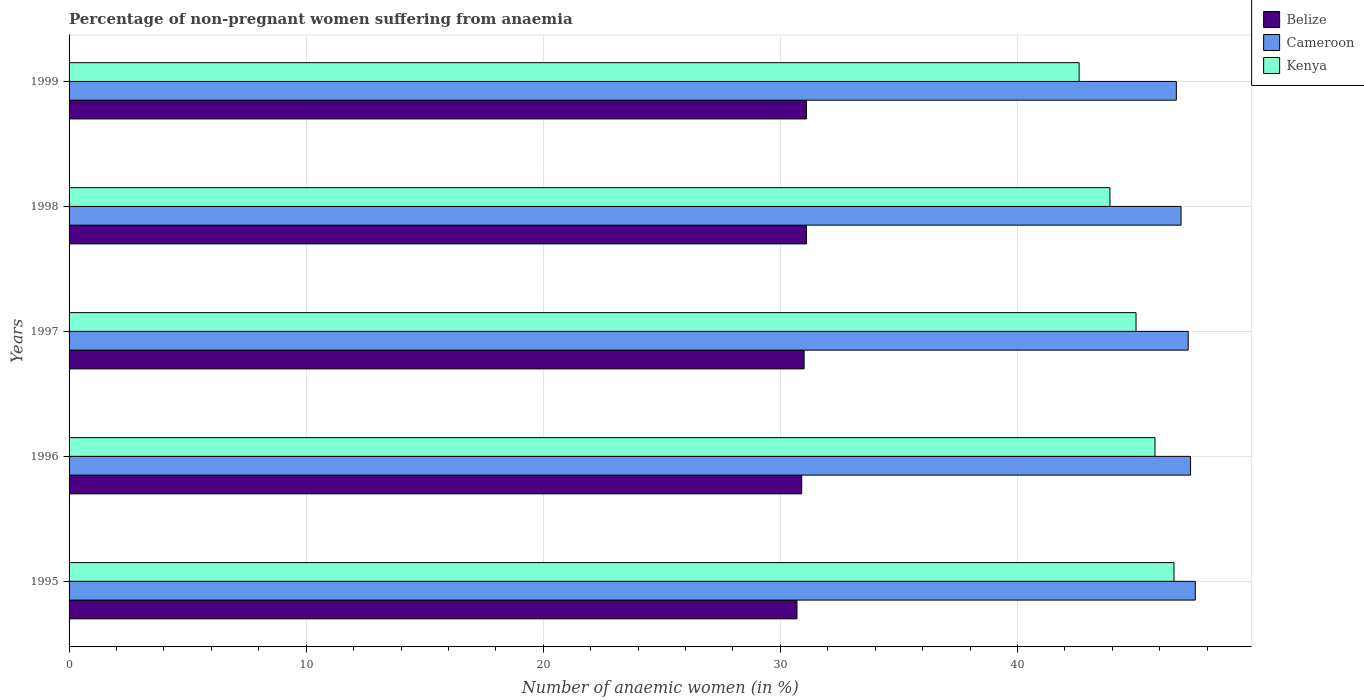How many groups of bars are there?
Your answer should be compact. 5. How many bars are there on the 4th tick from the top?
Keep it short and to the point. 3. In how many cases, is the number of bars for a given year not equal to the number of legend labels?
Offer a terse response. 0. Across all years, what is the maximum percentage of non-pregnant women suffering from anaemia in Kenya?
Provide a short and direct response. 46.6. Across all years, what is the minimum percentage of non-pregnant women suffering from anaemia in Cameroon?
Your answer should be compact. 46.7. In which year was the percentage of non-pregnant women suffering from anaemia in Kenya minimum?
Your answer should be very brief. 1999. What is the total percentage of non-pregnant women suffering from anaemia in Belize in the graph?
Offer a very short reply. 154.8. What is the difference between the percentage of non-pregnant women suffering from anaemia in Belize in 1995 and that in 1996?
Your answer should be compact. -0.2. What is the difference between the percentage of non-pregnant women suffering from anaemia in Kenya in 1996 and the percentage of non-pregnant women suffering from anaemia in Belize in 1998?
Offer a terse response. 14.7. What is the average percentage of non-pregnant women suffering from anaemia in Kenya per year?
Offer a terse response. 44.78. In the year 1996, what is the difference between the percentage of non-pregnant women suffering from anaemia in Belize and percentage of non-pregnant women suffering from anaemia in Kenya?
Your answer should be compact. -14.9. In how many years, is the percentage of non-pregnant women suffering from anaemia in Kenya greater than 46 %?
Offer a terse response. 1. What is the ratio of the percentage of non-pregnant women suffering from anaemia in Belize in 1995 to that in 1999?
Keep it short and to the point. 0.99. Is the percentage of non-pregnant women suffering from anaemia in Belize in 1996 less than that in 1997?
Your response must be concise. Yes. What is the difference between the highest and the second highest percentage of non-pregnant women suffering from anaemia in Kenya?
Provide a succinct answer. 0.8. What is the difference between the highest and the lowest percentage of non-pregnant women suffering from anaemia in Belize?
Make the answer very short. 0.4. Is the sum of the percentage of non-pregnant women suffering from anaemia in Cameroon in 1995 and 1996 greater than the maximum percentage of non-pregnant women suffering from anaemia in Belize across all years?
Offer a terse response. Yes. What does the 3rd bar from the top in 1999 represents?
Your answer should be very brief. Belize. What does the 3rd bar from the bottom in 1996 represents?
Provide a short and direct response. Kenya. Is it the case that in every year, the sum of the percentage of non-pregnant women suffering from anaemia in Belize and percentage of non-pregnant women suffering from anaemia in Kenya is greater than the percentage of non-pregnant women suffering from anaemia in Cameroon?
Give a very brief answer. Yes. Are the values on the major ticks of X-axis written in scientific E-notation?
Keep it short and to the point. No. How many legend labels are there?
Give a very brief answer. 3. What is the title of the graph?
Your response must be concise. Percentage of non-pregnant women suffering from anaemia. What is the label or title of the X-axis?
Your answer should be very brief. Number of anaemic women (in %). What is the label or title of the Y-axis?
Ensure brevity in your answer.  Years. What is the Number of anaemic women (in %) of Belize in 1995?
Offer a very short reply. 30.7. What is the Number of anaemic women (in %) in Cameroon in 1995?
Your response must be concise. 47.5. What is the Number of anaemic women (in %) in Kenya in 1995?
Your answer should be compact. 46.6. What is the Number of anaemic women (in %) of Belize in 1996?
Offer a terse response. 30.9. What is the Number of anaemic women (in %) in Cameroon in 1996?
Your response must be concise. 47.3. What is the Number of anaemic women (in %) in Kenya in 1996?
Offer a terse response. 45.8. What is the Number of anaemic women (in %) in Belize in 1997?
Keep it short and to the point. 31. What is the Number of anaemic women (in %) of Cameroon in 1997?
Your answer should be compact. 47.2. What is the Number of anaemic women (in %) in Kenya in 1997?
Keep it short and to the point. 45. What is the Number of anaemic women (in %) of Belize in 1998?
Provide a succinct answer. 31.1. What is the Number of anaemic women (in %) of Cameroon in 1998?
Your answer should be very brief. 46.9. What is the Number of anaemic women (in %) of Kenya in 1998?
Make the answer very short. 43.9. What is the Number of anaemic women (in %) of Belize in 1999?
Your answer should be compact. 31.1. What is the Number of anaemic women (in %) in Cameroon in 1999?
Offer a terse response. 46.7. What is the Number of anaemic women (in %) in Kenya in 1999?
Your answer should be compact. 42.6. Across all years, what is the maximum Number of anaemic women (in %) of Belize?
Give a very brief answer. 31.1. Across all years, what is the maximum Number of anaemic women (in %) of Cameroon?
Make the answer very short. 47.5. Across all years, what is the maximum Number of anaemic women (in %) in Kenya?
Make the answer very short. 46.6. Across all years, what is the minimum Number of anaemic women (in %) in Belize?
Your answer should be compact. 30.7. Across all years, what is the minimum Number of anaemic women (in %) in Cameroon?
Provide a short and direct response. 46.7. Across all years, what is the minimum Number of anaemic women (in %) of Kenya?
Provide a short and direct response. 42.6. What is the total Number of anaemic women (in %) of Belize in the graph?
Your answer should be compact. 154.8. What is the total Number of anaemic women (in %) of Cameroon in the graph?
Ensure brevity in your answer.  235.6. What is the total Number of anaemic women (in %) of Kenya in the graph?
Ensure brevity in your answer.  223.9. What is the difference between the Number of anaemic women (in %) of Belize in 1995 and that in 1996?
Keep it short and to the point. -0.2. What is the difference between the Number of anaemic women (in %) in Cameroon in 1995 and that in 1996?
Your answer should be very brief. 0.2. What is the difference between the Number of anaemic women (in %) of Kenya in 1995 and that in 1996?
Make the answer very short. 0.8. What is the difference between the Number of anaemic women (in %) of Cameroon in 1995 and that in 1997?
Offer a very short reply. 0.3. What is the difference between the Number of anaemic women (in %) of Kenya in 1995 and that in 1997?
Offer a very short reply. 1.6. What is the difference between the Number of anaemic women (in %) in Kenya in 1995 and that in 1998?
Your response must be concise. 2.7. What is the difference between the Number of anaemic women (in %) in Kenya in 1995 and that in 1999?
Offer a terse response. 4. What is the difference between the Number of anaemic women (in %) of Kenya in 1996 and that in 1998?
Your answer should be very brief. 1.9. What is the difference between the Number of anaemic women (in %) in Belize in 1997 and that in 1998?
Your answer should be compact. -0.1. What is the difference between the Number of anaemic women (in %) of Cameroon in 1997 and that in 1998?
Ensure brevity in your answer.  0.3. What is the difference between the Number of anaemic women (in %) of Kenya in 1997 and that in 1998?
Provide a succinct answer. 1.1. What is the difference between the Number of anaemic women (in %) of Belize in 1997 and that in 1999?
Ensure brevity in your answer.  -0.1. What is the difference between the Number of anaemic women (in %) in Cameroon in 1998 and that in 1999?
Provide a short and direct response. 0.2. What is the difference between the Number of anaemic women (in %) of Belize in 1995 and the Number of anaemic women (in %) of Cameroon in 1996?
Offer a terse response. -16.6. What is the difference between the Number of anaemic women (in %) of Belize in 1995 and the Number of anaemic women (in %) of Kenya in 1996?
Provide a succinct answer. -15.1. What is the difference between the Number of anaemic women (in %) in Cameroon in 1995 and the Number of anaemic women (in %) in Kenya in 1996?
Your answer should be very brief. 1.7. What is the difference between the Number of anaemic women (in %) in Belize in 1995 and the Number of anaemic women (in %) in Cameroon in 1997?
Your answer should be compact. -16.5. What is the difference between the Number of anaemic women (in %) of Belize in 1995 and the Number of anaemic women (in %) of Kenya in 1997?
Give a very brief answer. -14.3. What is the difference between the Number of anaemic women (in %) in Cameroon in 1995 and the Number of anaemic women (in %) in Kenya in 1997?
Your response must be concise. 2.5. What is the difference between the Number of anaemic women (in %) in Belize in 1995 and the Number of anaemic women (in %) in Cameroon in 1998?
Provide a succinct answer. -16.2. What is the difference between the Number of anaemic women (in %) of Belize in 1995 and the Number of anaemic women (in %) of Cameroon in 1999?
Your response must be concise. -16. What is the difference between the Number of anaemic women (in %) of Belize in 1995 and the Number of anaemic women (in %) of Kenya in 1999?
Your response must be concise. -11.9. What is the difference between the Number of anaemic women (in %) in Belize in 1996 and the Number of anaemic women (in %) in Cameroon in 1997?
Your answer should be compact. -16.3. What is the difference between the Number of anaemic women (in %) of Belize in 1996 and the Number of anaemic women (in %) of Kenya in 1997?
Your response must be concise. -14.1. What is the difference between the Number of anaemic women (in %) of Belize in 1996 and the Number of anaemic women (in %) of Kenya in 1998?
Offer a very short reply. -13. What is the difference between the Number of anaemic women (in %) in Cameroon in 1996 and the Number of anaemic women (in %) in Kenya in 1998?
Your answer should be very brief. 3.4. What is the difference between the Number of anaemic women (in %) in Belize in 1996 and the Number of anaemic women (in %) in Cameroon in 1999?
Give a very brief answer. -15.8. What is the difference between the Number of anaemic women (in %) in Belize in 1996 and the Number of anaemic women (in %) in Kenya in 1999?
Give a very brief answer. -11.7. What is the difference between the Number of anaemic women (in %) in Belize in 1997 and the Number of anaemic women (in %) in Cameroon in 1998?
Ensure brevity in your answer.  -15.9. What is the difference between the Number of anaemic women (in %) of Cameroon in 1997 and the Number of anaemic women (in %) of Kenya in 1998?
Make the answer very short. 3.3. What is the difference between the Number of anaemic women (in %) in Belize in 1997 and the Number of anaemic women (in %) in Cameroon in 1999?
Offer a very short reply. -15.7. What is the difference between the Number of anaemic women (in %) of Belize in 1997 and the Number of anaemic women (in %) of Kenya in 1999?
Your response must be concise. -11.6. What is the difference between the Number of anaemic women (in %) of Belize in 1998 and the Number of anaemic women (in %) of Cameroon in 1999?
Offer a very short reply. -15.6. What is the difference between the Number of anaemic women (in %) in Belize in 1998 and the Number of anaemic women (in %) in Kenya in 1999?
Your answer should be very brief. -11.5. What is the difference between the Number of anaemic women (in %) of Cameroon in 1998 and the Number of anaemic women (in %) of Kenya in 1999?
Make the answer very short. 4.3. What is the average Number of anaemic women (in %) in Belize per year?
Give a very brief answer. 30.96. What is the average Number of anaemic women (in %) in Cameroon per year?
Provide a short and direct response. 47.12. What is the average Number of anaemic women (in %) in Kenya per year?
Your answer should be compact. 44.78. In the year 1995, what is the difference between the Number of anaemic women (in %) of Belize and Number of anaemic women (in %) of Cameroon?
Your answer should be compact. -16.8. In the year 1995, what is the difference between the Number of anaemic women (in %) in Belize and Number of anaemic women (in %) in Kenya?
Give a very brief answer. -15.9. In the year 1996, what is the difference between the Number of anaemic women (in %) in Belize and Number of anaemic women (in %) in Cameroon?
Ensure brevity in your answer.  -16.4. In the year 1996, what is the difference between the Number of anaemic women (in %) of Belize and Number of anaemic women (in %) of Kenya?
Give a very brief answer. -14.9. In the year 1996, what is the difference between the Number of anaemic women (in %) in Cameroon and Number of anaemic women (in %) in Kenya?
Give a very brief answer. 1.5. In the year 1997, what is the difference between the Number of anaemic women (in %) of Belize and Number of anaemic women (in %) of Cameroon?
Your answer should be very brief. -16.2. In the year 1998, what is the difference between the Number of anaemic women (in %) of Belize and Number of anaemic women (in %) of Cameroon?
Offer a very short reply. -15.8. In the year 1998, what is the difference between the Number of anaemic women (in %) of Belize and Number of anaemic women (in %) of Kenya?
Keep it short and to the point. -12.8. In the year 1999, what is the difference between the Number of anaemic women (in %) in Belize and Number of anaemic women (in %) in Cameroon?
Ensure brevity in your answer.  -15.6. In the year 1999, what is the difference between the Number of anaemic women (in %) of Belize and Number of anaemic women (in %) of Kenya?
Offer a terse response. -11.5. What is the ratio of the Number of anaemic women (in %) in Belize in 1995 to that in 1996?
Offer a terse response. 0.99. What is the ratio of the Number of anaemic women (in %) in Kenya in 1995 to that in 1996?
Provide a short and direct response. 1.02. What is the ratio of the Number of anaemic women (in %) of Belize in 1995 to that in 1997?
Offer a very short reply. 0.99. What is the ratio of the Number of anaemic women (in %) of Cameroon in 1995 to that in 1997?
Provide a short and direct response. 1.01. What is the ratio of the Number of anaemic women (in %) in Kenya in 1995 to that in 1997?
Offer a very short reply. 1.04. What is the ratio of the Number of anaemic women (in %) of Belize in 1995 to that in 1998?
Offer a very short reply. 0.99. What is the ratio of the Number of anaemic women (in %) of Cameroon in 1995 to that in 1998?
Make the answer very short. 1.01. What is the ratio of the Number of anaemic women (in %) of Kenya in 1995 to that in 1998?
Give a very brief answer. 1.06. What is the ratio of the Number of anaemic women (in %) in Belize in 1995 to that in 1999?
Provide a succinct answer. 0.99. What is the ratio of the Number of anaemic women (in %) of Cameroon in 1995 to that in 1999?
Ensure brevity in your answer.  1.02. What is the ratio of the Number of anaemic women (in %) of Kenya in 1995 to that in 1999?
Your response must be concise. 1.09. What is the ratio of the Number of anaemic women (in %) in Belize in 1996 to that in 1997?
Provide a short and direct response. 1. What is the ratio of the Number of anaemic women (in %) of Kenya in 1996 to that in 1997?
Give a very brief answer. 1.02. What is the ratio of the Number of anaemic women (in %) in Cameroon in 1996 to that in 1998?
Provide a short and direct response. 1.01. What is the ratio of the Number of anaemic women (in %) in Kenya in 1996 to that in 1998?
Provide a succinct answer. 1.04. What is the ratio of the Number of anaemic women (in %) of Cameroon in 1996 to that in 1999?
Give a very brief answer. 1.01. What is the ratio of the Number of anaemic women (in %) of Kenya in 1996 to that in 1999?
Your answer should be compact. 1.08. What is the ratio of the Number of anaemic women (in %) of Belize in 1997 to that in 1998?
Give a very brief answer. 1. What is the ratio of the Number of anaemic women (in %) of Cameroon in 1997 to that in 1998?
Provide a succinct answer. 1.01. What is the ratio of the Number of anaemic women (in %) in Kenya in 1997 to that in 1998?
Make the answer very short. 1.03. What is the ratio of the Number of anaemic women (in %) in Cameroon in 1997 to that in 1999?
Provide a short and direct response. 1.01. What is the ratio of the Number of anaemic women (in %) in Kenya in 1997 to that in 1999?
Make the answer very short. 1.06. What is the ratio of the Number of anaemic women (in %) in Kenya in 1998 to that in 1999?
Provide a short and direct response. 1.03. What is the difference between the highest and the second highest Number of anaemic women (in %) of Belize?
Offer a very short reply. 0. What is the difference between the highest and the second highest Number of anaemic women (in %) in Cameroon?
Give a very brief answer. 0.2. What is the difference between the highest and the lowest Number of anaemic women (in %) of Kenya?
Offer a very short reply. 4. 